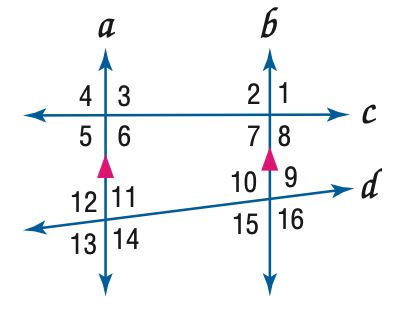Question: In the figure, m \angle 4 = 104, m \angle 14 = 118. Find the measure of \angle 7.
Choices:
A. 66
B. 76
C. 104
D. 118
Answer with the letter. Answer: B Question: In the figure, m \angle 4 = 104, m \angle 14 = 118. Find the measure of \angle 9.
Choices:
A. 62
B. 76
C. 104
D. 118
Answer with the letter. Answer: A Question: In the figure, m \angle 4 = 104, m \angle 14 = 118. Find the measure of \angle 10.
Choices:
A. 62
B. 76
C. 104
D. 118
Answer with the letter. Answer: D 